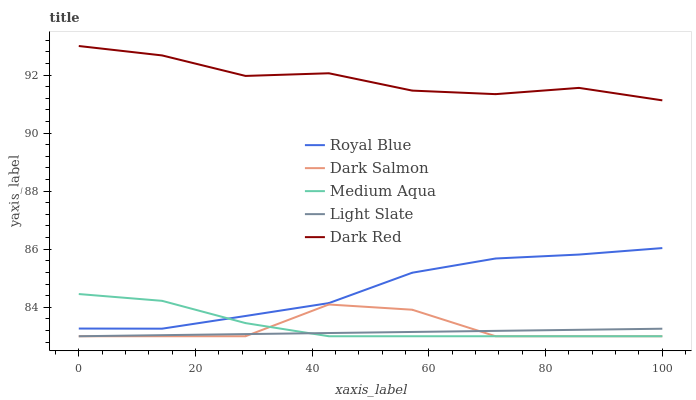Does Royal Blue have the minimum area under the curve?
Answer yes or no. No. Does Royal Blue have the maximum area under the curve?
Answer yes or no. No. Is Royal Blue the smoothest?
Answer yes or no. No. Is Royal Blue the roughest?
Answer yes or no. No. Does Royal Blue have the lowest value?
Answer yes or no. No. Does Royal Blue have the highest value?
Answer yes or no. No. Is Medium Aqua less than Dark Red?
Answer yes or no. Yes. Is Royal Blue greater than Light Slate?
Answer yes or no. Yes. Does Medium Aqua intersect Dark Red?
Answer yes or no. No. 